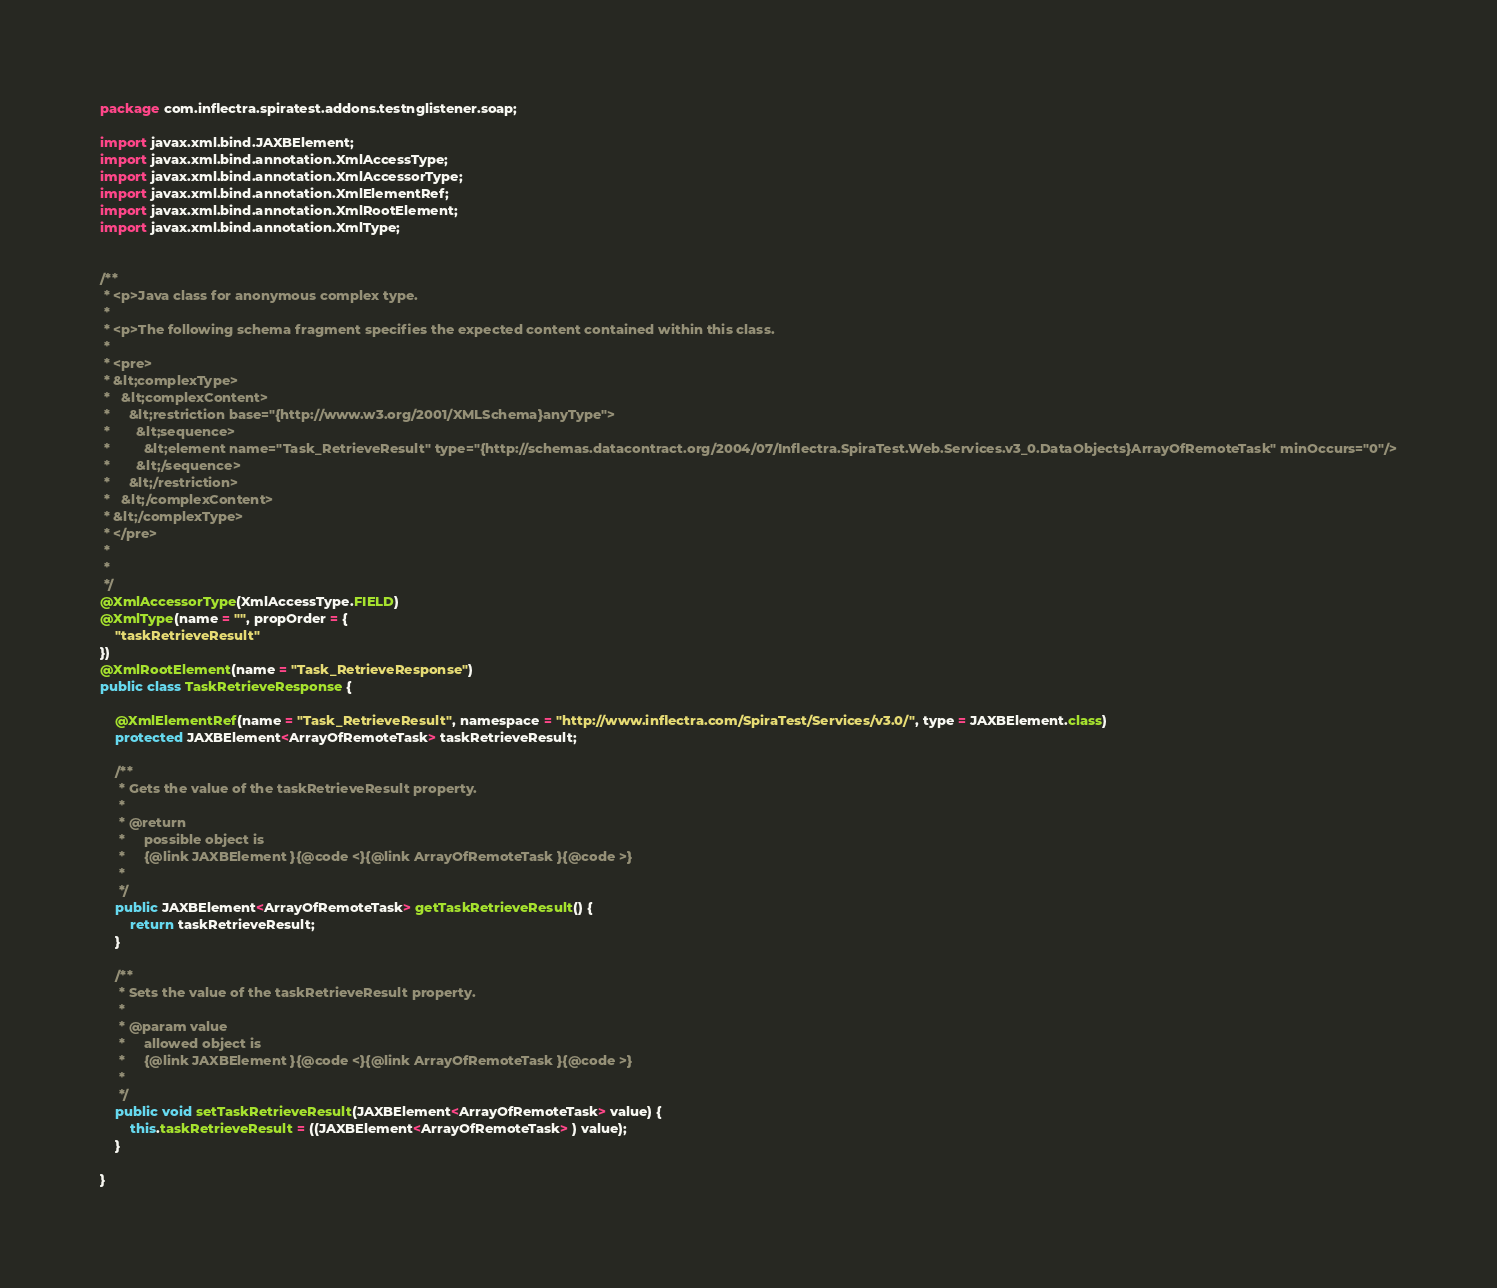Convert code to text. <code><loc_0><loc_0><loc_500><loc_500><_Java_>
package com.inflectra.spiratest.addons.testnglistener.soap;

import javax.xml.bind.JAXBElement;
import javax.xml.bind.annotation.XmlAccessType;
import javax.xml.bind.annotation.XmlAccessorType;
import javax.xml.bind.annotation.XmlElementRef;
import javax.xml.bind.annotation.XmlRootElement;
import javax.xml.bind.annotation.XmlType;


/**
 * <p>Java class for anonymous complex type.
 * 
 * <p>The following schema fragment specifies the expected content contained within this class.
 * 
 * <pre>
 * &lt;complexType>
 *   &lt;complexContent>
 *     &lt;restriction base="{http://www.w3.org/2001/XMLSchema}anyType">
 *       &lt;sequence>
 *         &lt;element name="Task_RetrieveResult" type="{http://schemas.datacontract.org/2004/07/Inflectra.SpiraTest.Web.Services.v3_0.DataObjects}ArrayOfRemoteTask" minOccurs="0"/>
 *       &lt;/sequence>
 *     &lt;/restriction>
 *   &lt;/complexContent>
 * &lt;/complexType>
 * </pre>
 * 
 * 
 */
@XmlAccessorType(XmlAccessType.FIELD)
@XmlType(name = "", propOrder = {
    "taskRetrieveResult"
})
@XmlRootElement(name = "Task_RetrieveResponse")
public class TaskRetrieveResponse {

    @XmlElementRef(name = "Task_RetrieveResult", namespace = "http://www.inflectra.com/SpiraTest/Services/v3.0/", type = JAXBElement.class)
    protected JAXBElement<ArrayOfRemoteTask> taskRetrieveResult;

    /**
     * Gets the value of the taskRetrieveResult property.
     * 
     * @return
     *     possible object is
     *     {@link JAXBElement }{@code <}{@link ArrayOfRemoteTask }{@code >}
     *     
     */
    public JAXBElement<ArrayOfRemoteTask> getTaskRetrieveResult() {
        return taskRetrieveResult;
    }

    /**
     * Sets the value of the taskRetrieveResult property.
     * 
     * @param value
     *     allowed object is
     *     {@link JAXBElement }{@code <}{@link ArrayOfRemoteTask }{@code >}
     *     
     */
    public void setTaskRetrieveResult(JAXBElement<ArrayOfRemoteTask> value) {
        this.taskRetrieveResult = ((JAXBElement<ArrayOfRemoteTask> ) value);
    }

}
</code> 